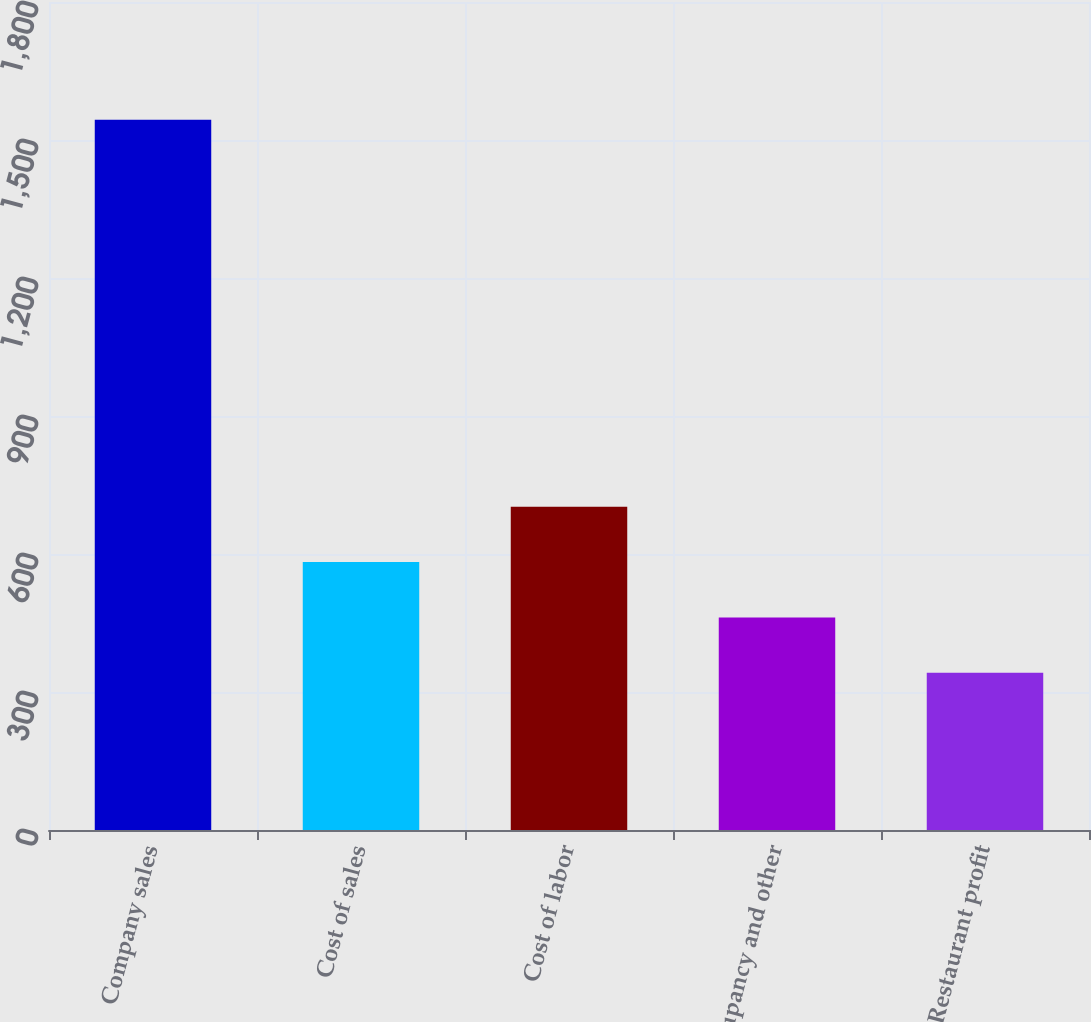Convert chart. <chart><loc_0><loc_0><loc_500><loc_500><bar_chart><fcel>Company sales<fcel>Cost of sales<fcel>Cost of labor<fcel>Occupancy and other<fcel>Restaurant profit<nl><fcel>1544<fcel>582.4<fcel>702.6<fcel>462.2<fcel>342<nl></chart> 